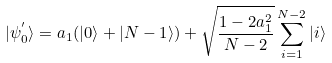<formula> <loc_0><loc_0><loc_500><loc_500>| \psi ^ { ^ { \prime } } _ { 0 } \rangle = a _ { 1 } ( | 0 \rangle + | { N - 1 } \rangle ) + \sqrt { \frac { 1 - 2 a _ { 1 } ^ { 2 } } { N - 2 } } \sum ^ { N - 2 } _ { i = 1 } | i \rangle</formula> 